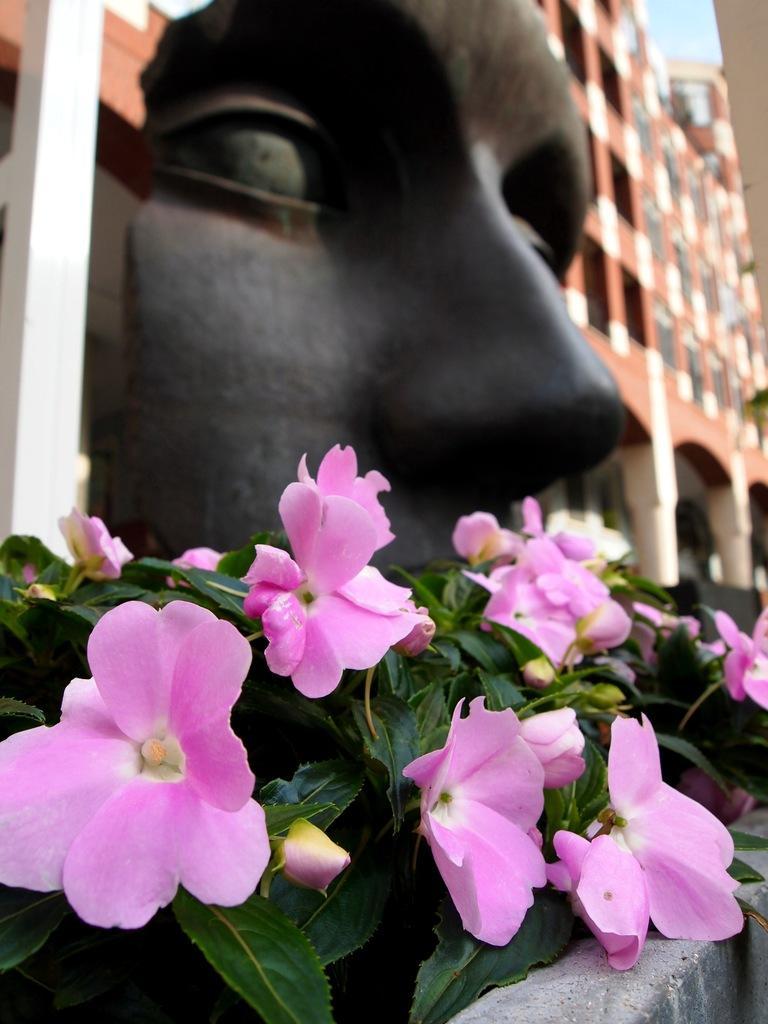Could you give a brief overview of what you see in this image? In this image we can see there is a building behind that there is a face sculpture and some flower plants in front of that. 